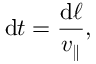Convert formula to latex. <formula><loc_0><loc_0><loc_500><loc_500>d t = \frac { d \ell } { v _ { \| } } ,</formula> 